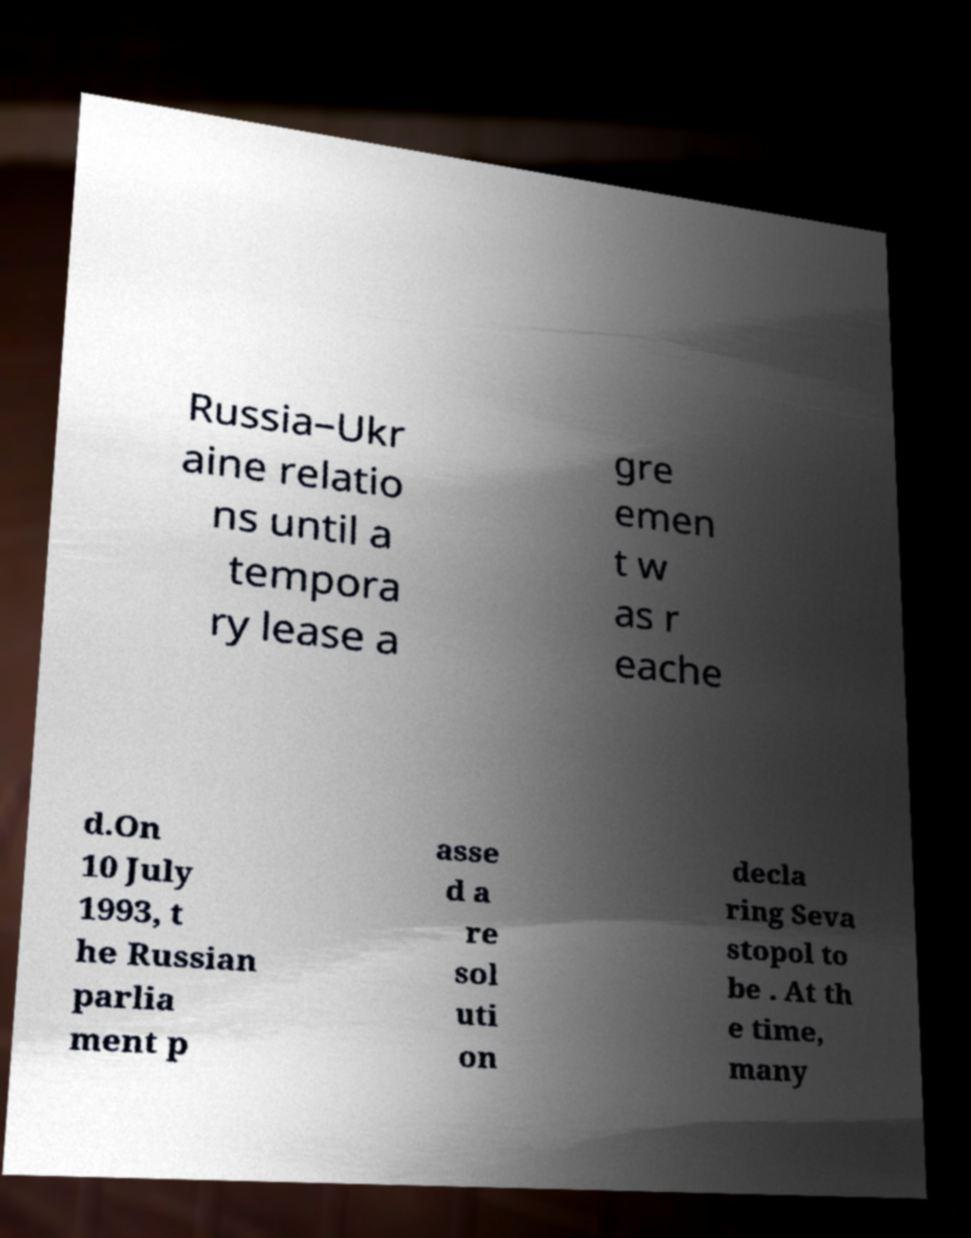What messages or text are displayed in this image? I need them in a readable, typed format. Russia–Ukr aine relatio ns until a tempora ry lease a gre emen t w as r eache d.On 10 July 1993, t he Russian parlia ment p asse d a re sol uti on decla ring Seva stopol to be . At th e time, many 